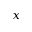Convert formula to latex. <formula><loc_0><loc_0><loc_500><loc_500>x</formula> 